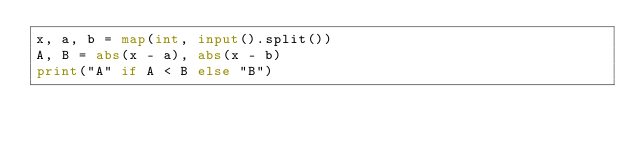<code> <loc_0><loc_0><loc_500><loc_500><_Python_>x, a, b = map(int, input().split())
A, B = abs(x - a), abs(x - b)
print("A" if A < B else "B")
</code> 